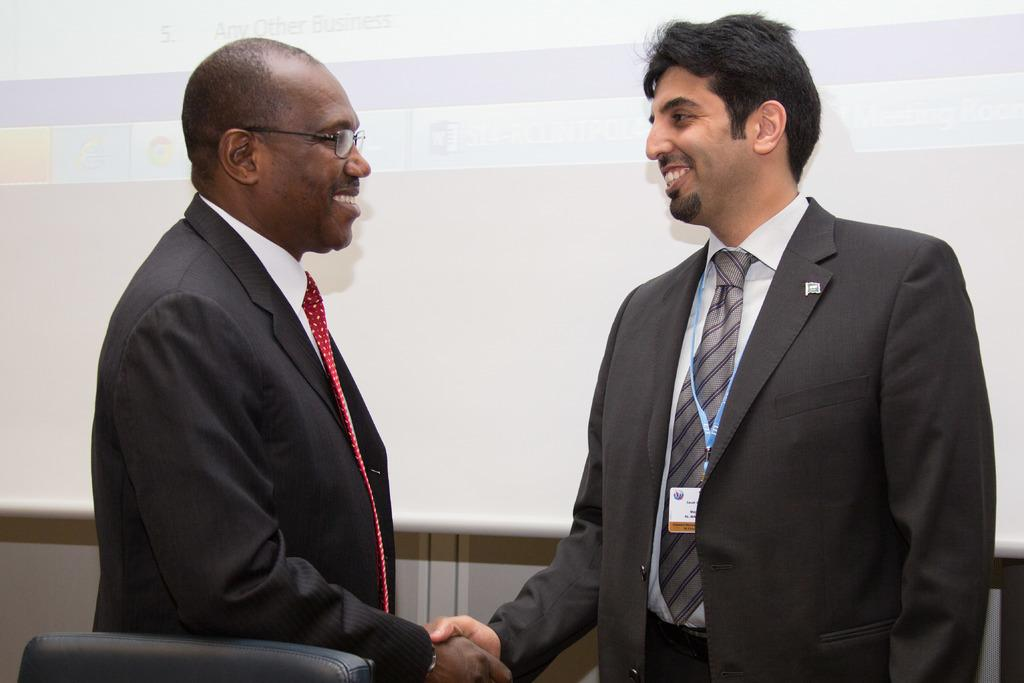How many people are in the image? There are two men in the image. What are the men doing in the image? The men are standing and shaking hands. What can be seen in the background of the image? There is a screen and a wall in the background of the image. What piece of furniture is present at the bottom of the image? There is a chair at the bottom of the image. What type of downtown development can be seen in the image? There is no downtown development present in the image; it features two men shaking hands with a screen and a wall in the background. 